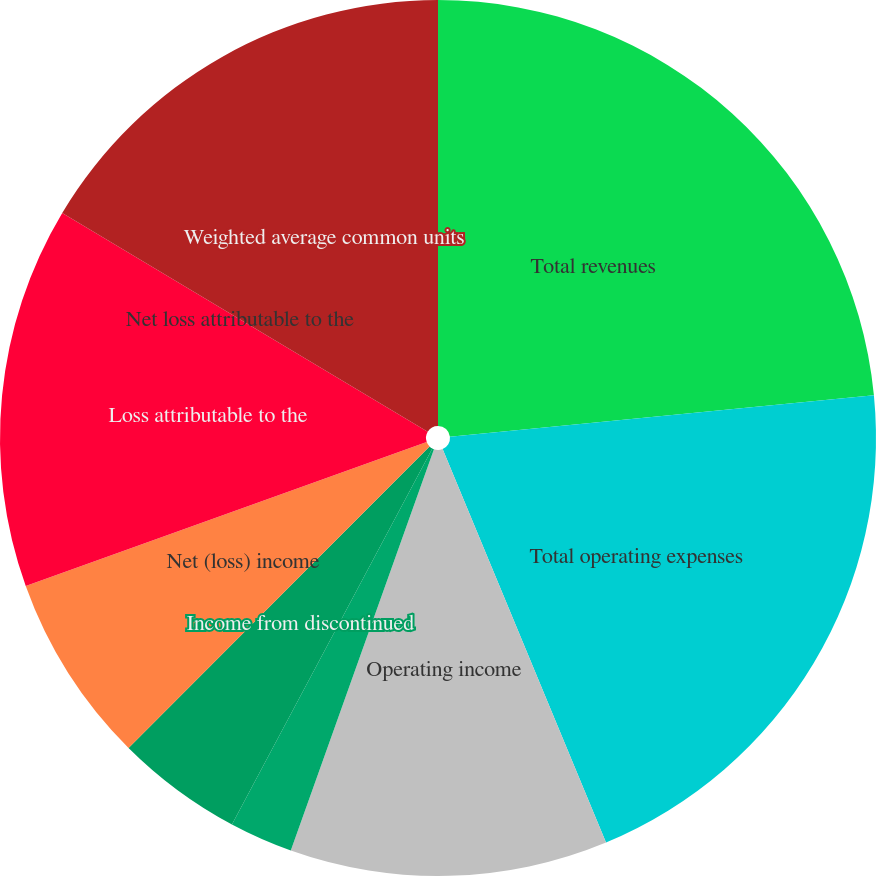Convert chart. <chart><loc_0><loc_0><loc_500><loc_500><pie_chart><fcel>Total revenues<fcel>Total operating expenses<fcel>Operating income<fcel>Loss from continuing<fcel>Income from discontinued<fcel>Net (loss) income<fcel>Loss attributable to the<fcel>Net loss attributable to the<fcel>Weighted average common units<nl><fcel>23.44%<fcel>20.29%<fcel>11.72%<fcel>2.34%<fcel>4.69%<fcel>7.03%<fcel>14.07%<fcel>0.0%<fcel>16.41%<nl></chart> 